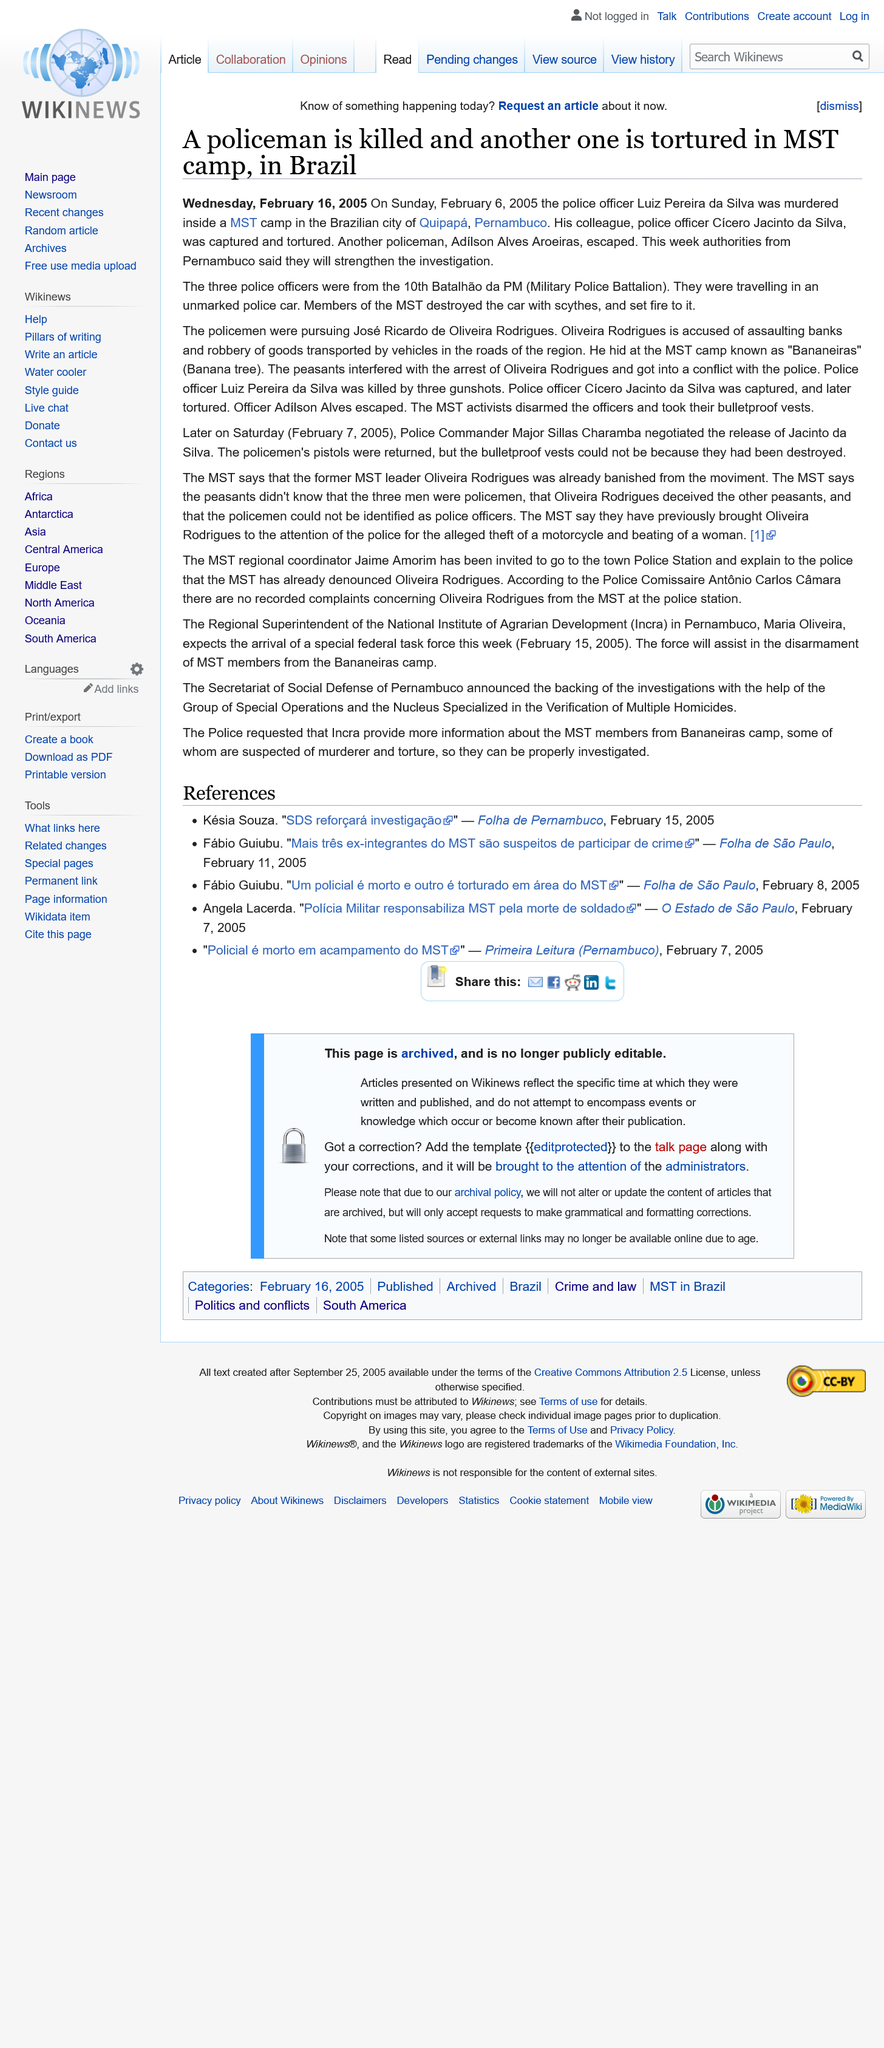Mention a couple of crucial points in this snapshot. In February 2005, at a MST camp in Brazil, a policeman was killed and another one was tortured. The third police officer, Adilson Alves Aroeiras, escaped after what happened. The MST camp is located in the Brazilian city of Quipapa, Pernambuco. 